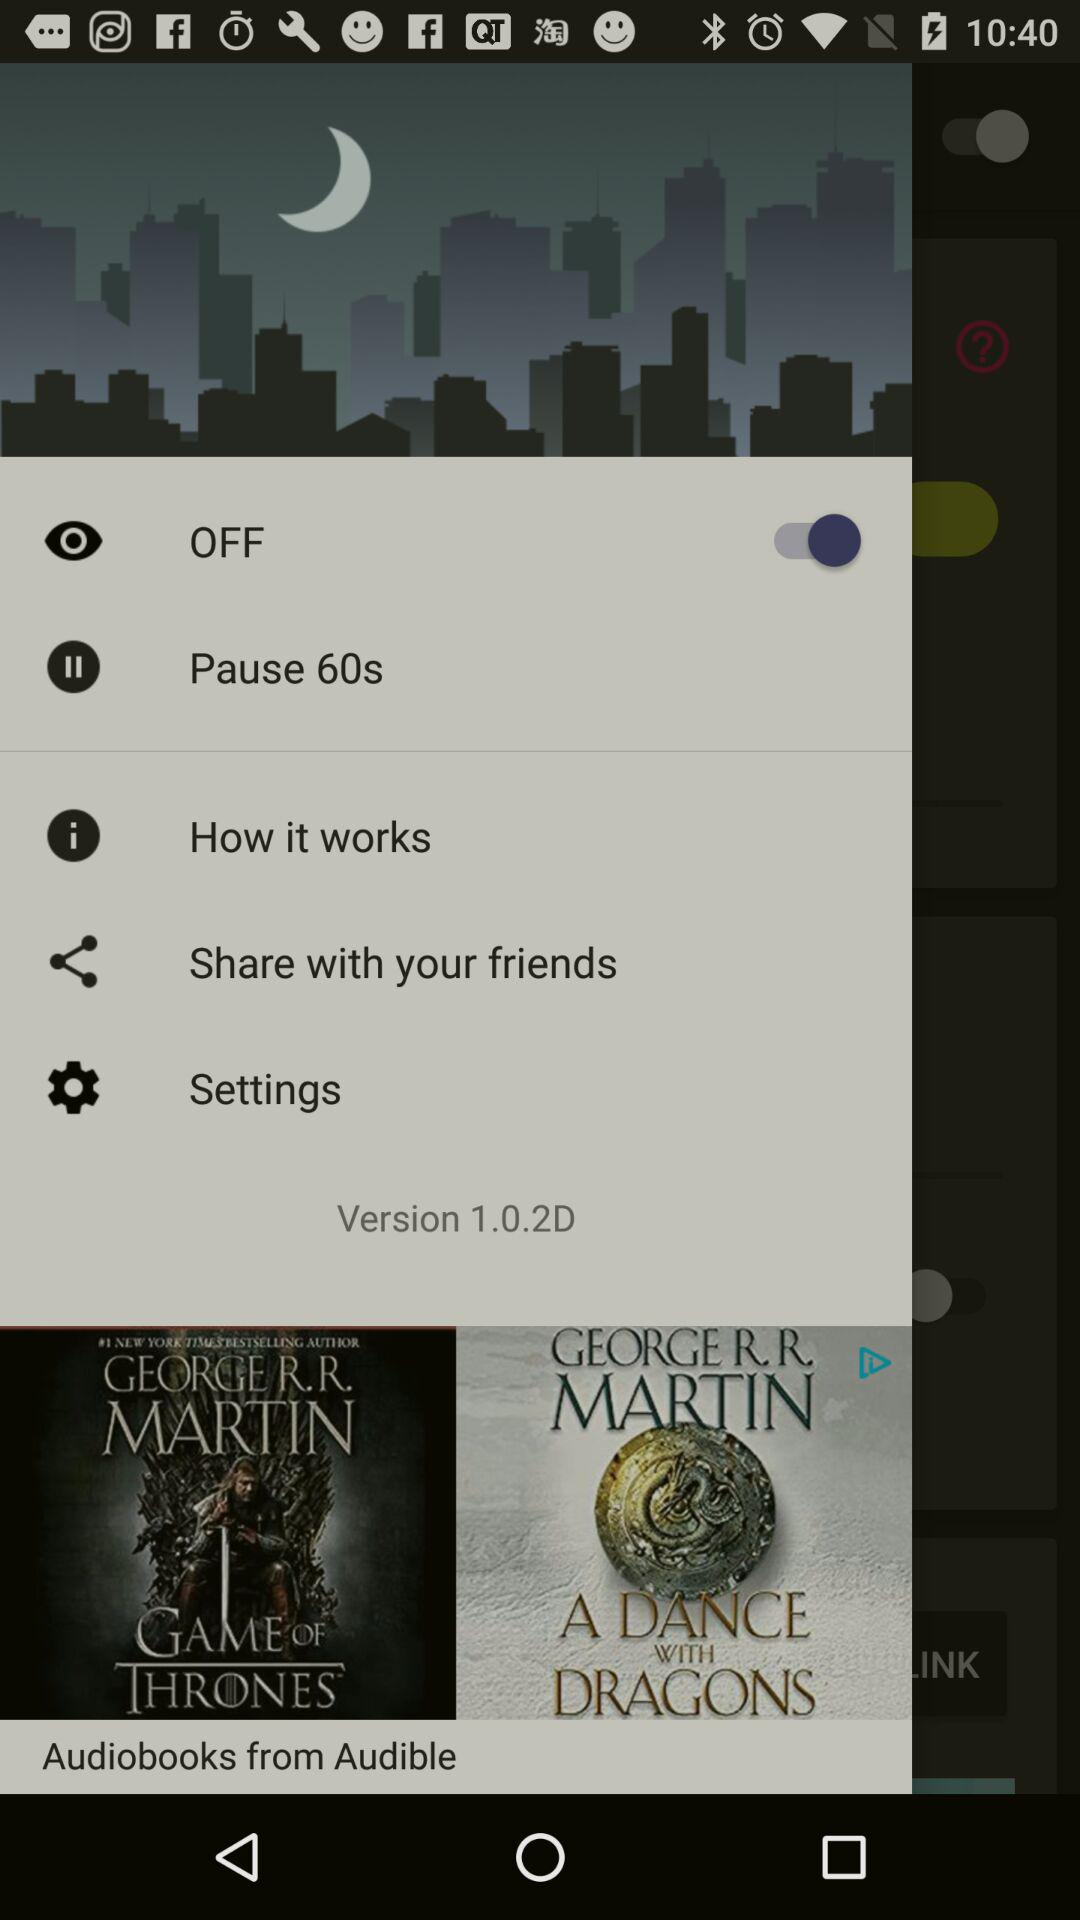What is the selected time for the pause? The selected time for the pause is 60 seconds. 